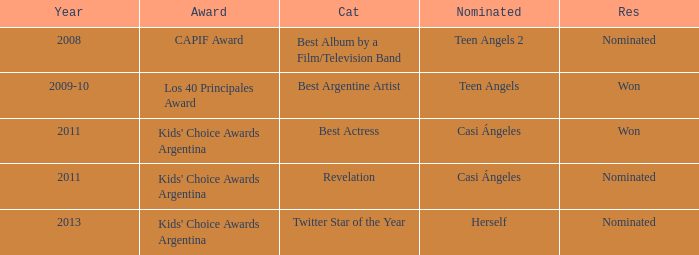What year was there a nomination for Best Actress at the Kids' Choice Awards Argentina? 2011.0. 